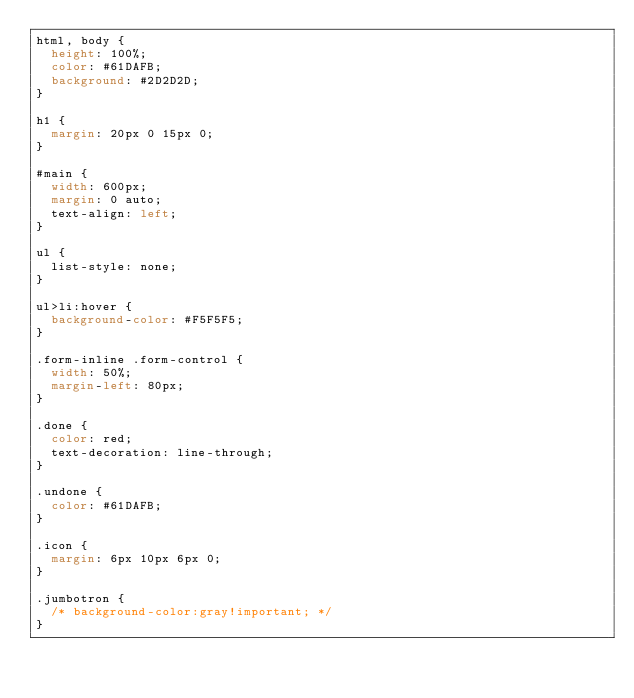<code> <loc_0><loc_0><loc_500><loc_500><_CSS_>html, body {
  height: 100%;
  color: #61DAFB;
  background: #2D2D2D;
}

h1 {
  margin: 20px 0 15px 0;  
}

#main {
  width: 600px;
  margin: 0 auto;
  text-align: left;
}

ul {
  list-style: none;
}

ul>li:hover {
  background-color: #F5F5F5;
}

.form-inline .form-control {
  width: 50%;
  margin-left: 80px;
}

.done {
  color: red;
  text-decoration: line-through;
}

.undone {
  color: #61DAFB;
}

.icon {
  margin: 6px 10px 6px 0;
}

.jumbotron {
  /* background-color:gray!important; */
}</code> 